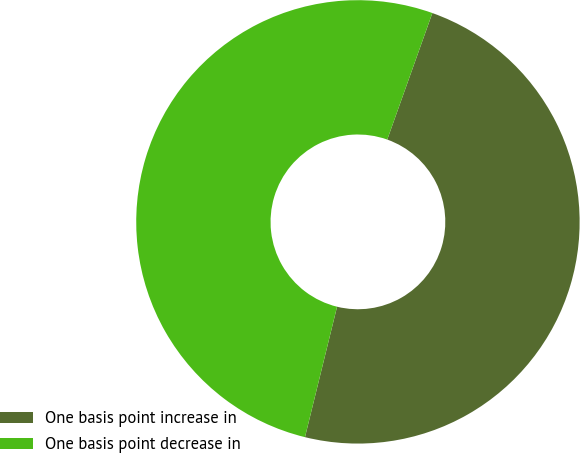Convert chart to OTSL. <chart><loc_0><loc_0><loc_500><loc_500><pie_chart><fcel>One basis point increase in<fcel>One basis point decrease in<nl><fcel>48.39%<fcel>51.61%<nl></chart> 